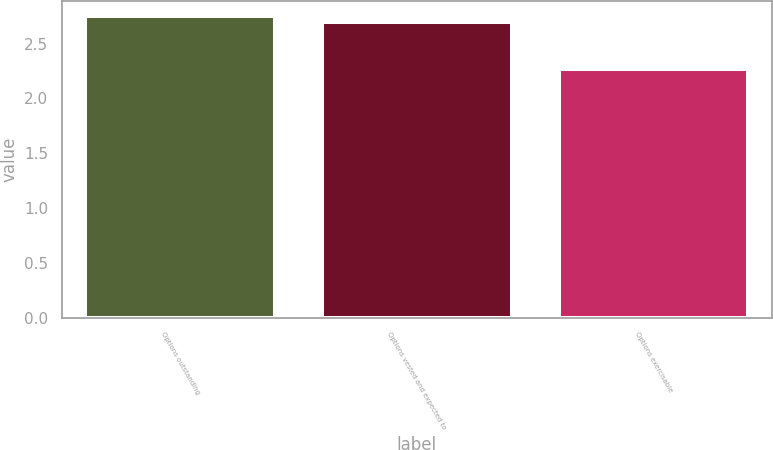<chart> <loc_0><loc_0><loc_500><loc_500><bar_chart><fcel>Options outstanding<fcel>Options vested and expected to<fcel>Options exercisable<nl><fcel>2.75<fcel>2.7<fcel>2.27<nl></chart> 